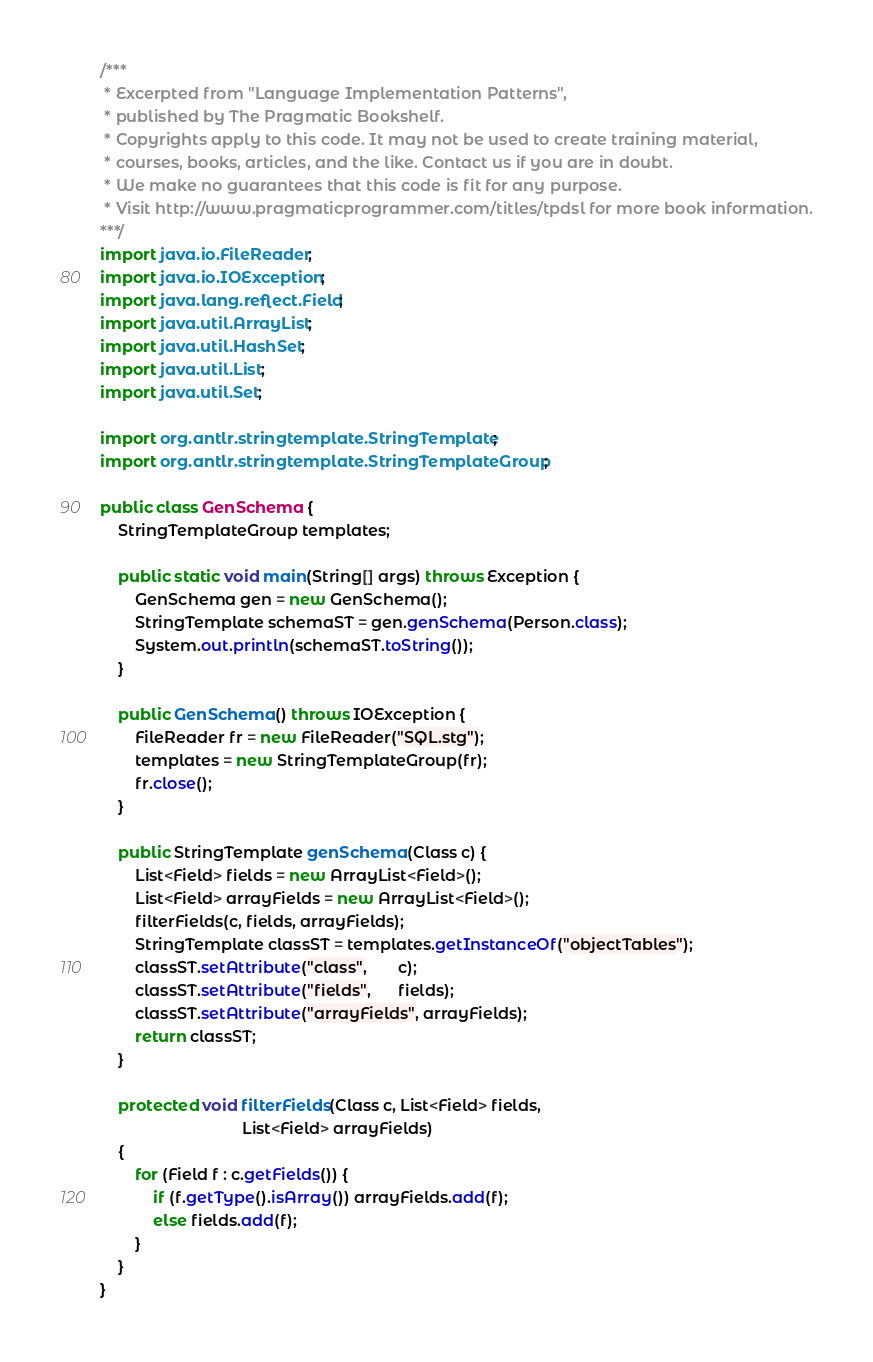Convert code to text. <code><loc_0><loc_0><loc_500><loc_500><_Java_>/***
 * Excerpted from "Language Implementation Patterns",
 * published by The Pragmatic Bookshelf.
 * Copyrights apply to this code. It may not be used to create training material, 
 * courses, books, articles, and the like. Contact us if you are in doubt.
 * We make no guarantees that this code is fit for any purpose. 
 * Visit http://www.pragmaticprogrammer.com/titles/tpdsl for more book information.
***/
import java.io.FileReader;
import java.io.IOException;
import java.lang.reflect.Field;
import java.util.ArrayList;
import java.util.HashSet;
import java.util.List;
import java.util.Set;

import org.antlr.stringtemplate.StringTemplate;
import org.antlr.stringtemplate.StringTemplateGroup;

public class GenSchema {
    StringTemplateGroup templates;
    
    public static void main(String[] args) throws Exception {
        GenSchema gen = new GenSchema();
        StringTemplate schemaST = gen.genSchema(Person.class);
        System.out.println(schemaST.toString());
    }
    
    public GenSchema() throws IOException {
        FileReader fr = new FileReader("SQL.stg");
        templates = new StringTemplateGroup(fr);
        fr.close();
    }

    public StringTemplate genSchema(Class c) {
        List<Field> fields = new ArrayList<Field>();
        List<Field> arrayFields = new ArrayList<Field>();
        filterFields(c, fields, arrayFields);
        StringTemplate classST = templates.getInstanceOf("objectTables");
        classST.setAttribute("class",       c);
        classST.setAttribute("fields",      fields);
        classST.setAttribute("arrayFields", arrayFields);
        return classST;
    }
    
    protected void filterFields(Class c, List<Field> fields,
                                List<Field> arrayFields)
    {
        for (Field f : c.getFields()) {
            if (f.getType().isArray()) arrayFields.add(f);
            else fields.add(f);
        }
    }
}
</code> 